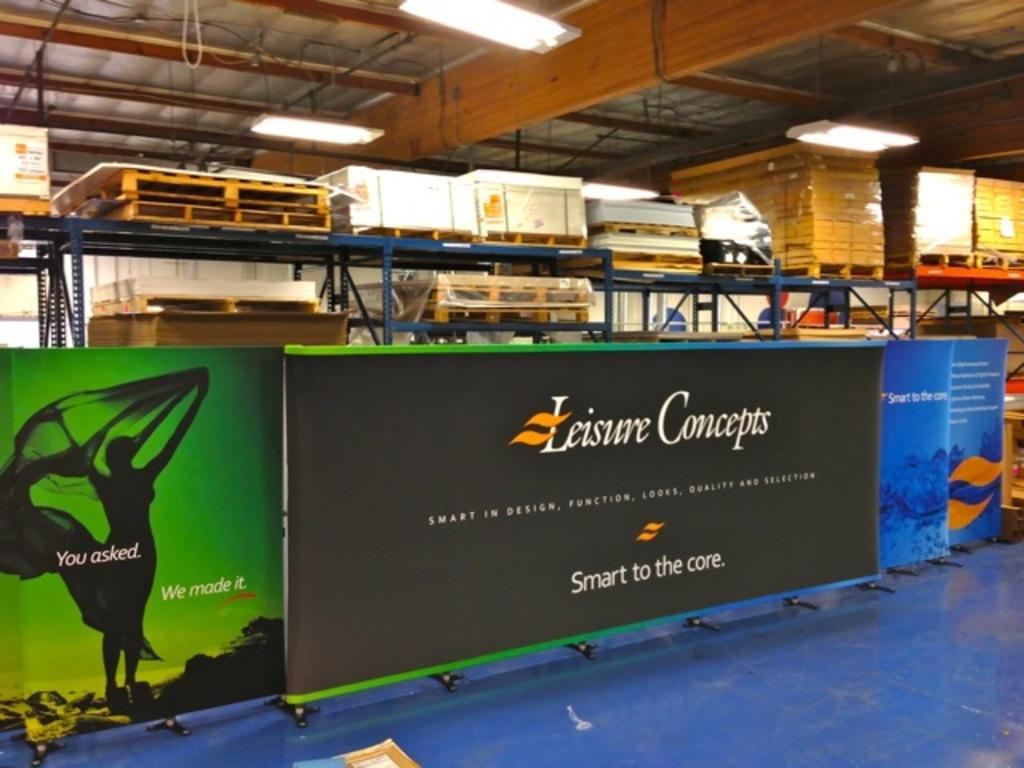<image>
Present a compact description of the photo's key features. Leisure Concepts Smart in design, function, looks, quality, and selection banner. 